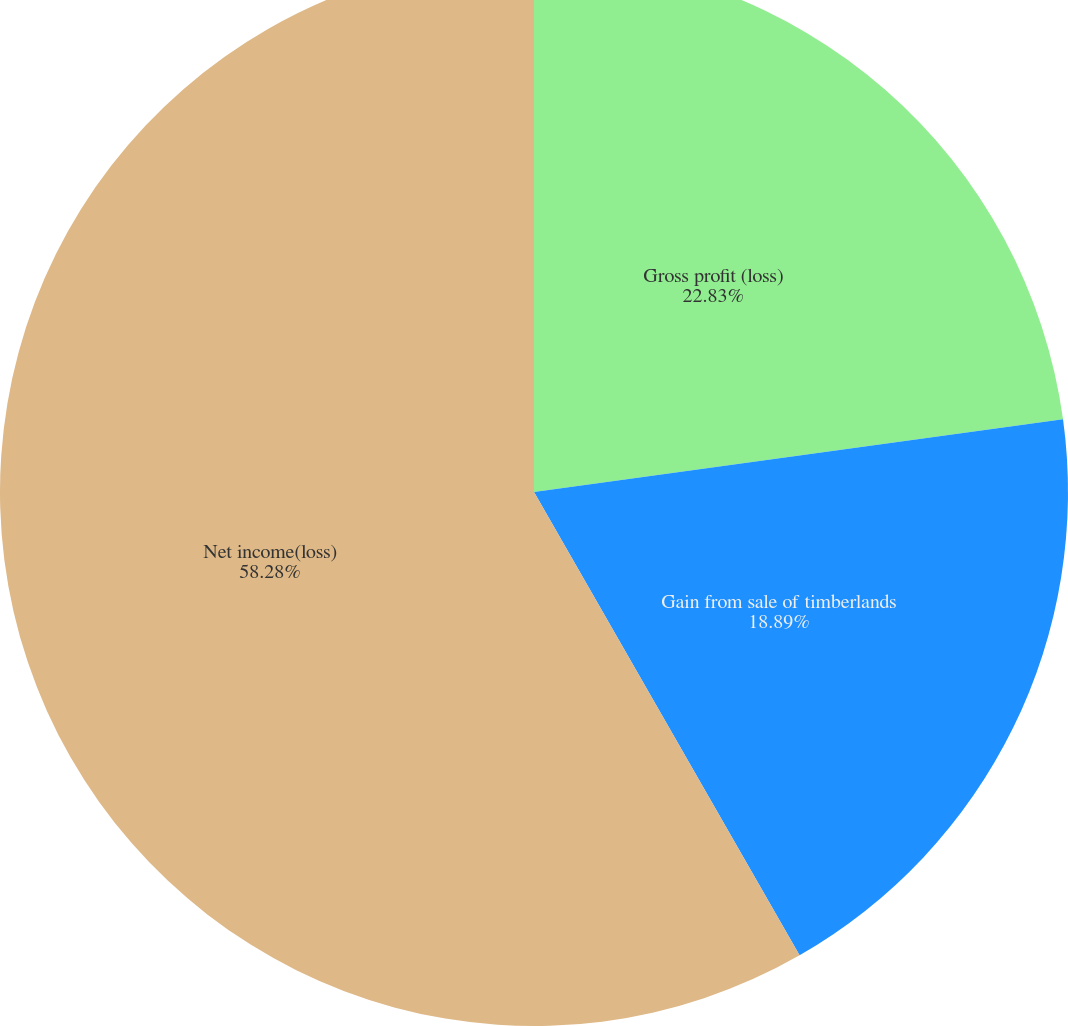Convert chart to OTSL. <chart><loc_0><loc_0><loc_500><loc_500><pie_chart><fcel>Gross profit (loss)<fcel>Gain from sale of timberlands<fcel>Net income(loss)<nl><fcel>22.83%<fcel>18.89%<fcel>58.29%<nl></chart> 